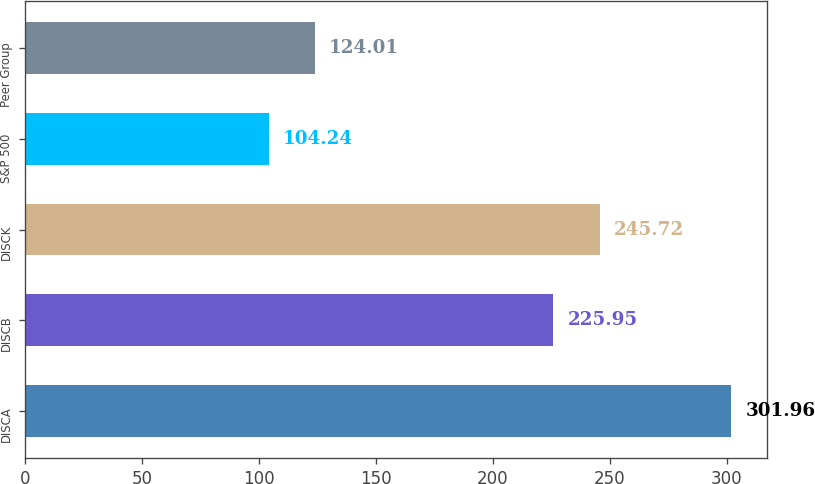<chart> <loc_0><loc_0><loc_500><loc_500><bar_chart><fcel>DISCA<fcel>DISCB<fcel>DISCK<fcel>S&P 500<fcel>Peer Group<nl><fcel>301.96<fcel>225.95<fcel>245.72<fcel>104.24<fcel>124.01<nl></chart> 